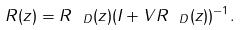<formula> <loc_0><loc_0><loc_500><loc_500>R ( z ) = R _ { \ D } ( z ) ( I + V R _ { \ D } ( z ) ) ^ { - 1 } .</formula> 